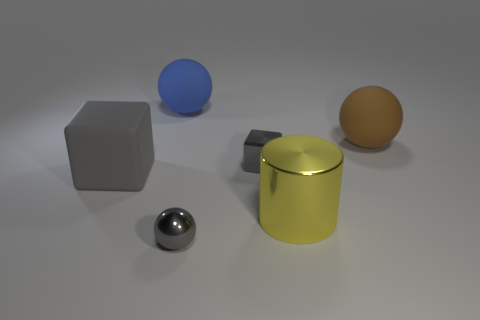How many gray cubes must be subtracted to get 1 gray cubes? 1 Subtract all rubber balls. How many balls are left? 1 Add 3 big gray blocks. How many objects exist? 9 Subtract 1 spheres. How many spheres are left? 2 Add 1 small purple metallic cylinders. How many small purple metallic cylinders exist? 1 Subtract all gray spheres. How many spheres are left? 2 Subtract 0 red blocks. How many objects are left? 6 Subtract all cubes. How many objects are left? 4 Subtract all yellow balls. Subtract all cyan blocks. How many balls are left? 3 Subtract all yellow spheres. How many brown cylinders are left? 0 